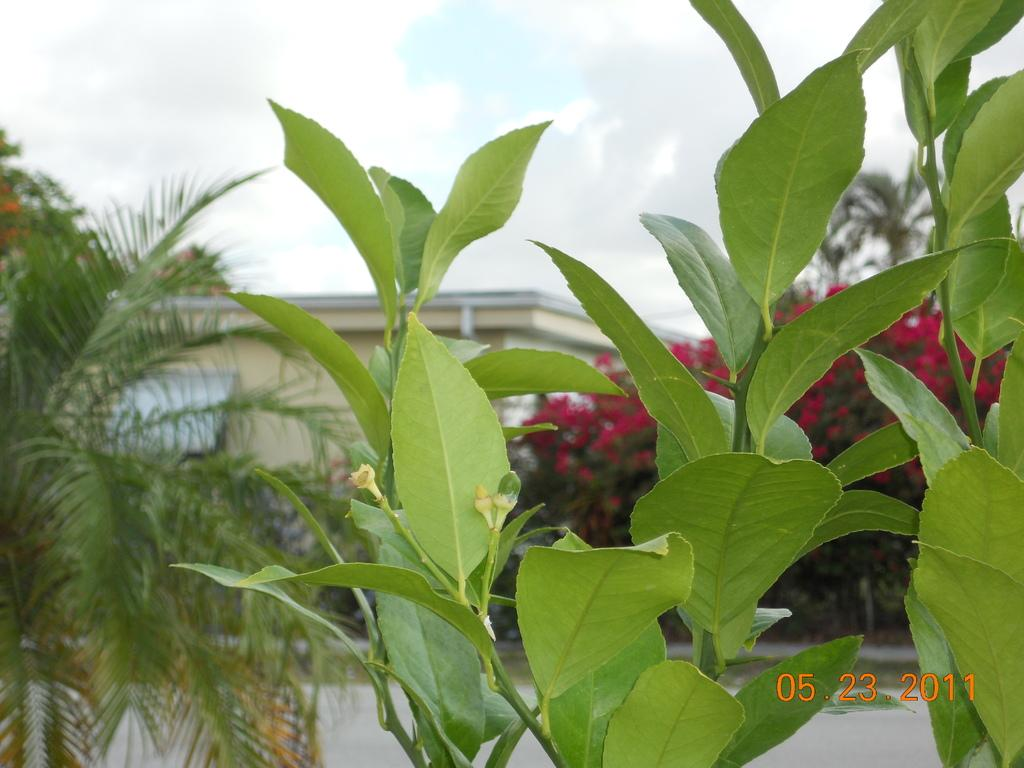What type of structure is present in the image? There is a building in the image. What other elements can be seen in the image besides the building? There are trees and the sky visible in the image. What is written or depicted at the bottom of the image? There is text at the bottom of the image. What type of surprise can be seen happening at night in the image? There is no surprise or nighttime depicted in the image; it features a building, trees, and the sky during the day. 